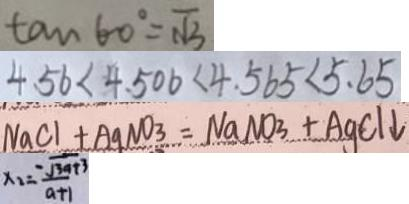Convert formula to latex. <formula><loc_0><loc_0><loc_500><loc_500>\tan 6 0 ^ { \circ } = \sqrt { 3 } 
 4 . 5 6 < 4 . 5 0 6 < 4 . 5 6 5 < 5 . 6 5 
 N a C l + A g N O _ { 3 } = N a N O _ { 3 } + A g C l \downarrow 
 x _ { 2 } = \frac { - \sqrt { 3 a + 3 } } { a + 1 }</formula> 